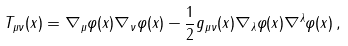<formula> <loc_0><loc_0><loc_500><loc_500>T _ { \mu \nu } ( x ) = \nabla _ { \mu } \varphi ( x ) \nabla _ { \nu } \varphi ( x ) - \frac { 1 } { 2 } g _ { \mu \nu } ( x ) \nabla _ { \lambda } \varphi ( x ) \nabla ^ { \lambda } \varphi ( x ) \, ,</formula> 